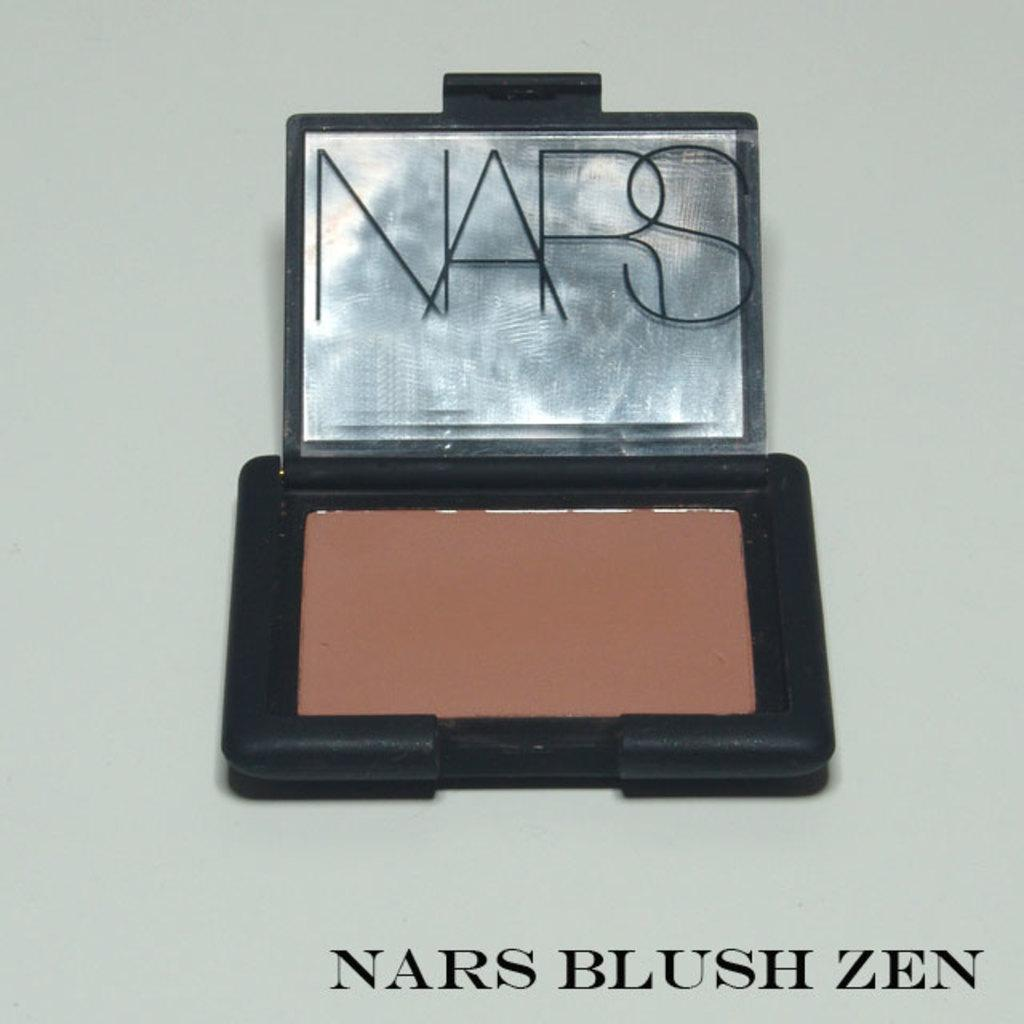Provide a one-sentence caption for the provided image. A blush kit made by the NARS company. 